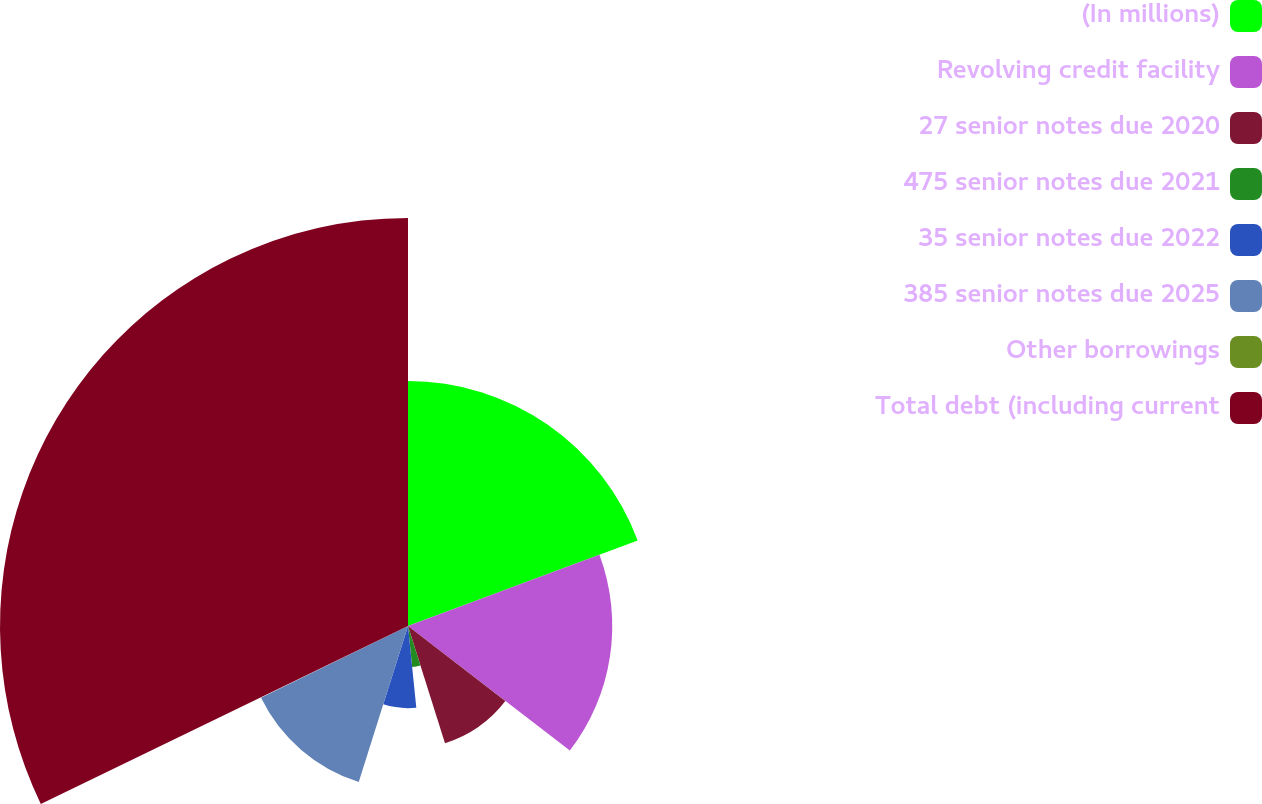Convert chart to OTSL. <chart><loc_0><loc_0><loc_500><loc_500><pie_chart><fcel>(In millions)<fcel>Revolving credit facility<fcel>27 senior notes due 2020<fcel>475 senior notes due 2021<fcel>35 senior notes due 2022<fcel>385 senior notes due 2025<fcel>Other borrowings<fcel>Total debt (including current<nl><fcel>19.33%<fcel>16.11%<fcel>9.69%<fcel>3.26%<fcel>6.48%<fcel>12.9%<fcel>0.05%<fcel>32.18%<nl></chart> 